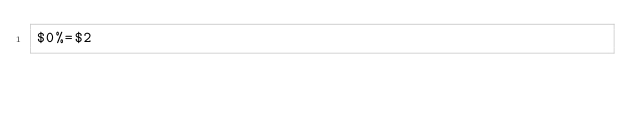<code> <loc_0><loc_0><loc_500><loc_500><_Awk_>$0%=$2</code> 